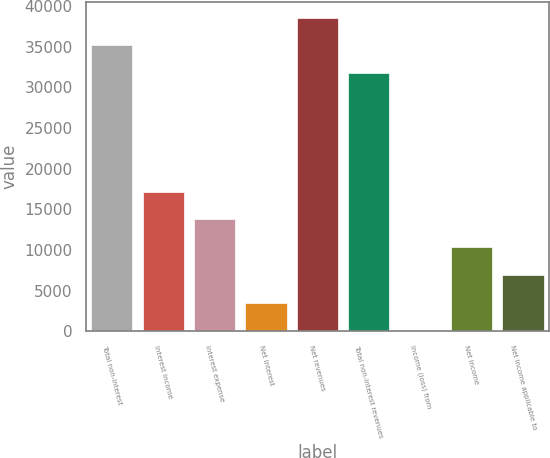Convert chart to OTSL. <chart><loc_0><loc_0><loc_500><loc_500><bar_chart><fcel>Total non-interest<fcel>Interest income<fcel>Interest expense<fcel>Net interest<fcel>Net revenues<fcel>Total non-interest revenues<fcel>Income (loss) from<fcel>Net income<fcel>Net income applicable to<nl><fcel>35135.3<fcel>17173.5<fcel>13753.2<fcel>3492.3<fcel>38555.6<fcel>31715<fcel>72<fcel>10332.9<fcel>6912.6<nl></chart> 